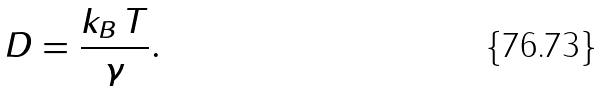Convert formula to latex. <formula><loc_0><loc_0><loc_500><loc_500>D = \frac { k _ { B } \, T } { \gamma } .</formula> 